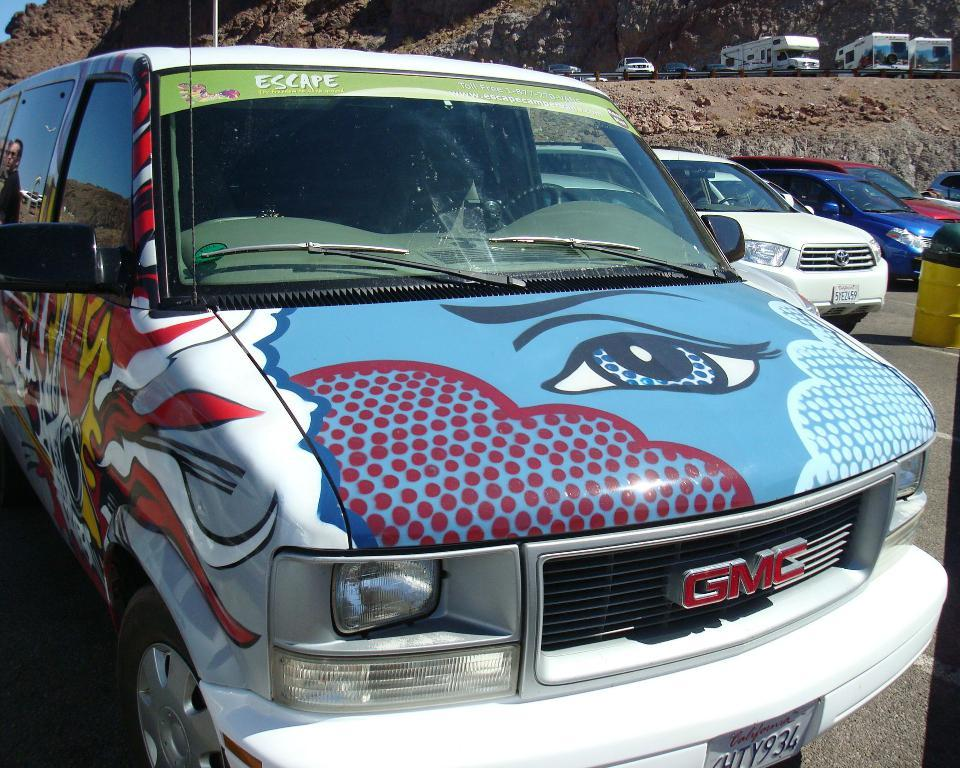Provide a one-sentence caption for the provided image. A vividly painted GMC van has a bright blue eye on its hood. 